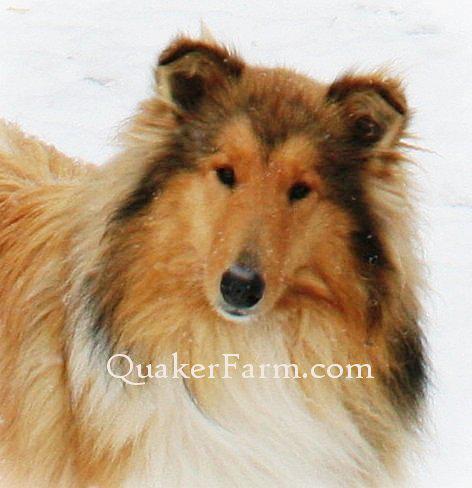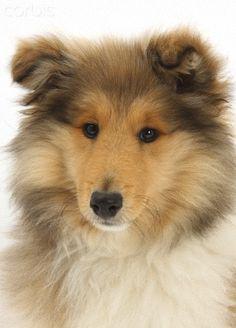The first image is the image on the left, the second image is the image on the right. For the images displayed, is the sentence "A collie is pictured on an outdoor light blue background." factually correct? Answer yes or no. No. 